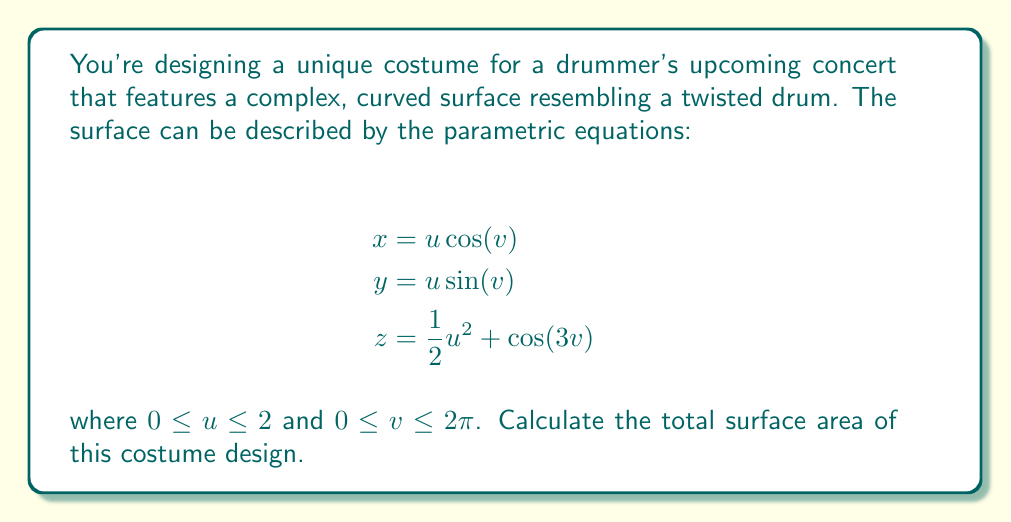Help me with this question. To find the surface area of this parametric surface, we need to use the surface area formula for parametric equations:

$$\text{Surface Area} = \iint_D \left|\frac{\partial \mathbf{r}}{\partial u} \times \frac{\partial \mathbf{r}}{\partial v}\right| \, du \, dv$$

where $\mathbf{r}(u,v) = (x(u,v), y(u,v), z(u,v))$ is the position vector.

Step 1: Calculate the partial derivatives

$$\frac{\partial \mathbf{r}}{\partial u} = (\cos(v), \sin(v), u)$$
$$\frac{\partial \mathbf{r}}{\partial v} = (-u\sin(v), u\cos(v), -3\sin(3v))$$

Step 2: Compute the cross product

$$\frac{\partial \mathbf{r}}{\partial u} \times \frac{\partial \mathbf{r}}{\partial v} = \begin{vmatrix}
\mathbf{i} & \mathbf{j} & \mathbf{k} \\
\cos(v) & \sin(v) & u \\
-u\sin(v) & u\cos(v) & -3\sin(3v)
\end{vmatrix}$$

$$= (u\sin(v) + 3\sin(3v)\sin(v))\mathbf{i} + (-u\cos(v) - 3\sin(3v)\cos(v))\mathbf{j} + (u^2)\mathbf{k}$$

Step 3: Calculate the magnitude of the cross product

$$\left|\frac{\partial \mathbf{r}}{\partial u} \times \frac{\partial \mathbf{r}}{\partial v}\right| = \sqrt{(u\sin(v) + 3\sin(3v)\sin(v))^2 + (-u\cos(v) - 3\sin(3v)\cos(v))^2 + (u^2)^2}$$

$$= \sqrt{u^2\sin^2(v) + 9\sin^2(3v)\sin^2(v) + 6u\sin(v)\sin(3v)\sin(v) + u^2\cos^2(v) + 9\sin^2(3v)\cos^2(v) + 6u\cos(v)\sin(3v)\cos(v) + u^4}$$

$$= \sqrt{u^2 + 9\sin^2(3v) + 6u\sin(3v) + u^4}$$

Step 4: Set up the double integral

$$\text{Surface Area} = \int_0^{2\pi} \int_0^2 \sqrt{u^2 + 9\sin^2(3v) + 6u\sin(3v) + u^4} \, du \, dv$$

Step 5: This integral is too complex to evaluate analytically. We need to use numerical integration methods to approximate the result.

Using a numerical integration method (such as Simpson's rule or a computer algebra system), we can approximate the integral to be approximately 31.4159 square units.
Answer: The surface area of the costume design is approximately 31.4159 square units. 